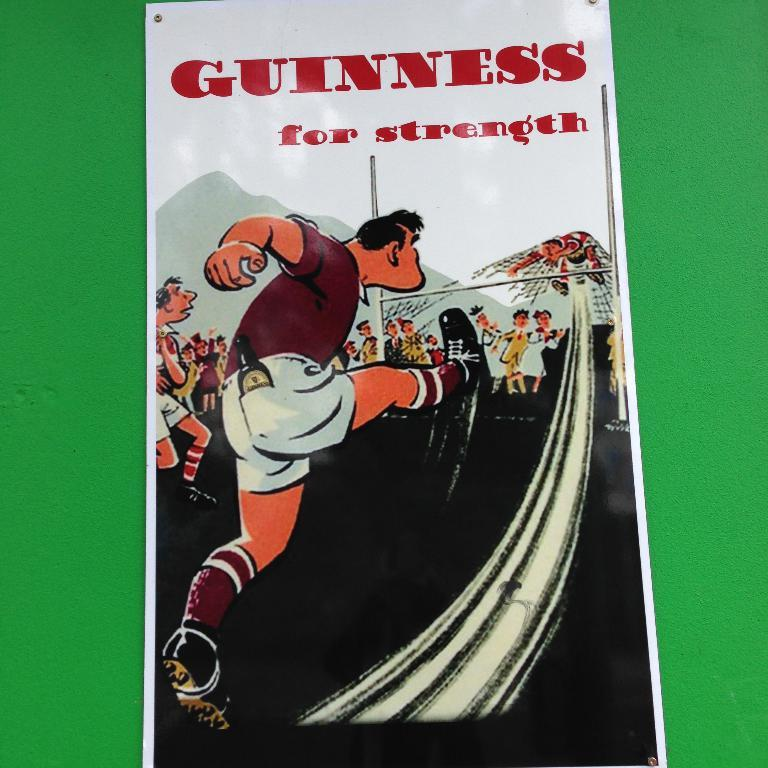<image>
Present a compact description of the photo's key features. An illustration of a man kicking another man under a goal with a bottle of Guinness in his back pocket. 